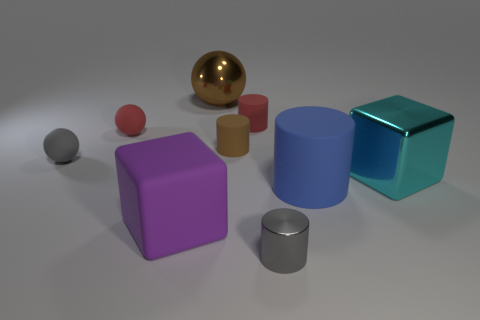How many cyan objects are either large objects or small metallic things? In the image, there is one large cyan cube, which satisfies the condition of being a large object. There are no small metallic objects that are cyan. Therefore, the total count of cyan objects that are either large or small and metallic is one. 